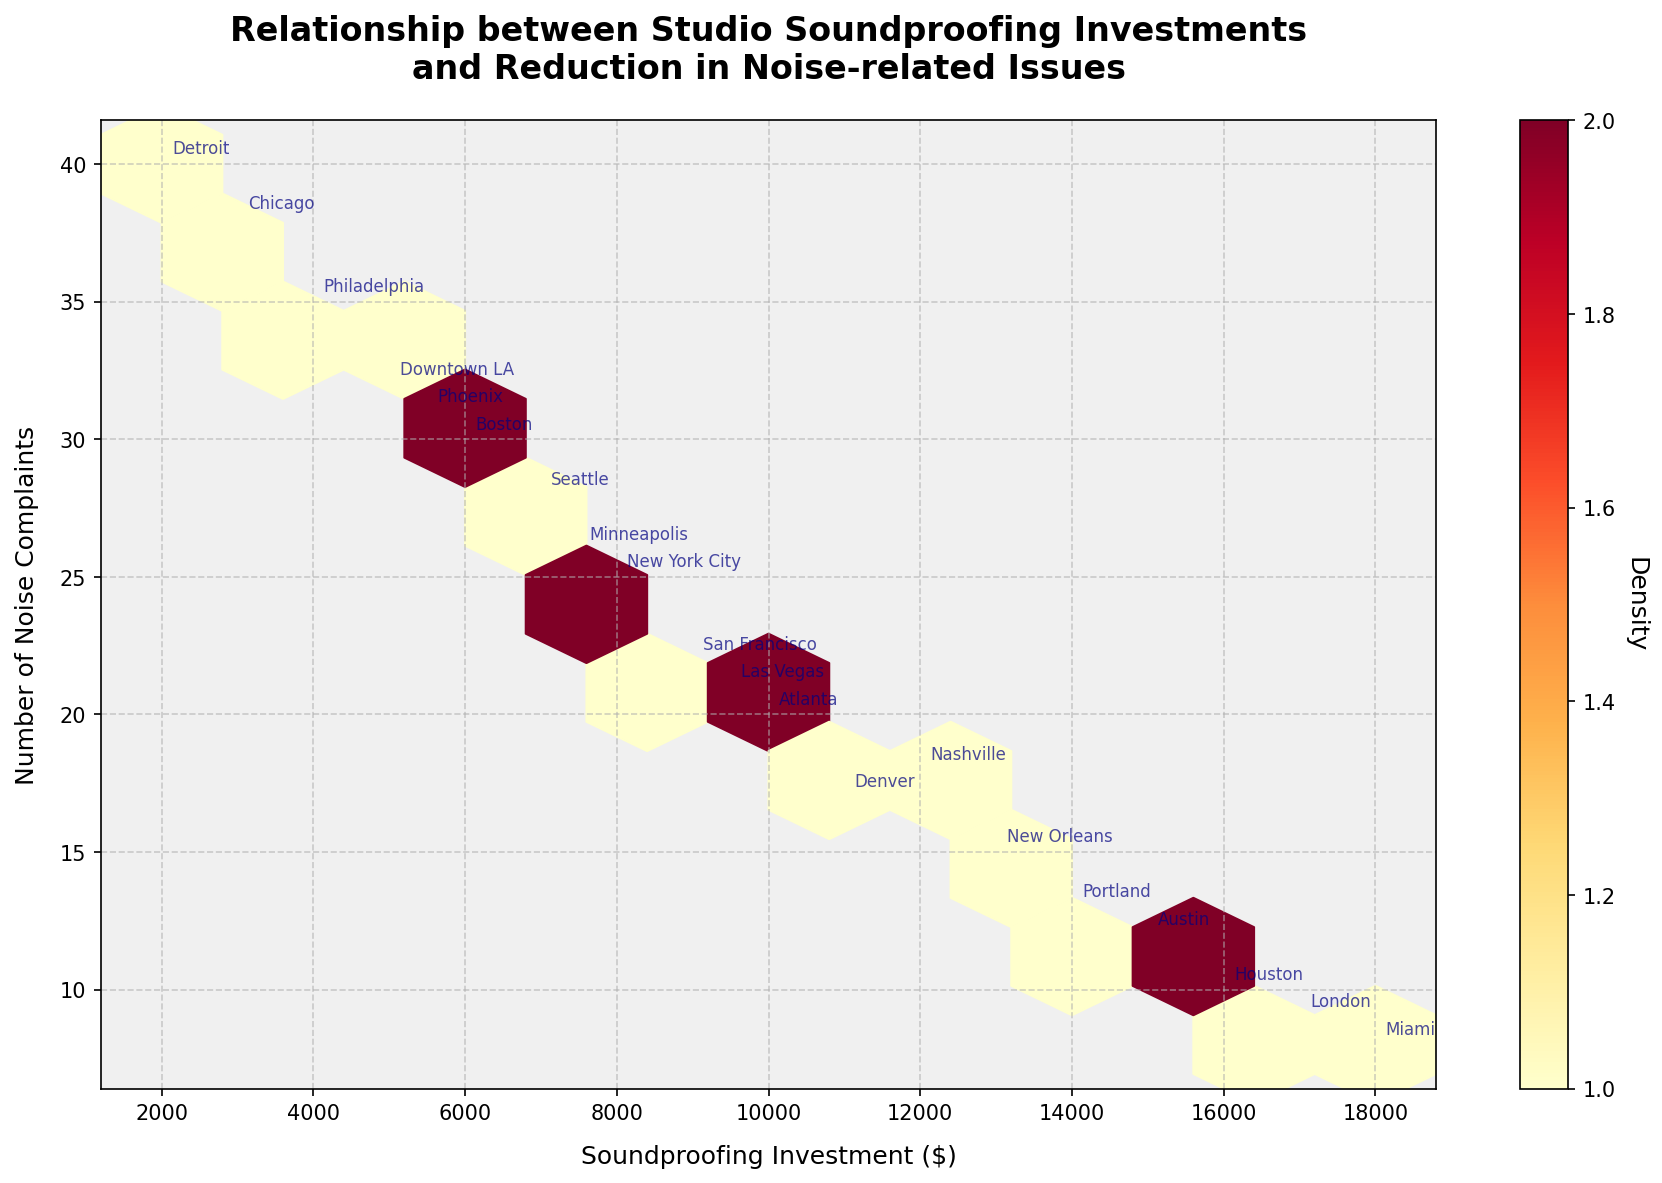How many data points are there in the plot? The plot annotates the studio locations, each corresponding to a single data point. Counting the names, there are 20 locations.
Answer: 20 What is the relationship between investment in soundproofing and noise complaints? Observing the plot, a general negative trend can be seen, suggesting that higher investment in soundproofing is associated with fewer noise complaints.
Answer: Negative correlation What range of investments covers the densest area in the plot? The color gradient of the hexagons indicates density. The densest hexagons are found between $8,000 and $12,000 of investment.
Answer: $8,000 to $12,000 Which city has the highest number of noise complaints and what is the corresponding investment? Detroit has the highest number (around 40) of noise complaints with $2,000 investment, as shown by the annotation close to the highest y-value.
Answer: Detroit, $2,000 How many noise complaints are there for studios with an investment of $15,000? From the annotations, Austin shows 12 noise complaints at an investment of $15,000.
Answer: 12 Does any city have both a high investment in soundproofing and a low number of noise complaints? Miami, with $18,000 invested, has 8 noise complaints, and London, with $17,000 invested, has 9 noise complaints, both considered low.
Answer: Miami and London Identify the city with the lowest investment and describe the number of noise complaints it faced. Detroit has the lowest investment of $2,000 and faces around 40 noise complaints, as noted in the annotation.
Answer: Detroit, around 40 What is the colormap used in the plot and what does it represent? The colormap 'YlOrRd' ranges from yellow to red. It represents the density of the data points; yellow indicates lower density, and red indicates higher density.
Answer: YlOrRd colormap representing density Which two cities with investments above $10,000 have the closest number of noise complaints? Nashville ($12,000 investment) with 18 complaints, and Denver ($11,000 investment) with 17 complaints, have the closest numbers.
Answer: Nashville and Denver 